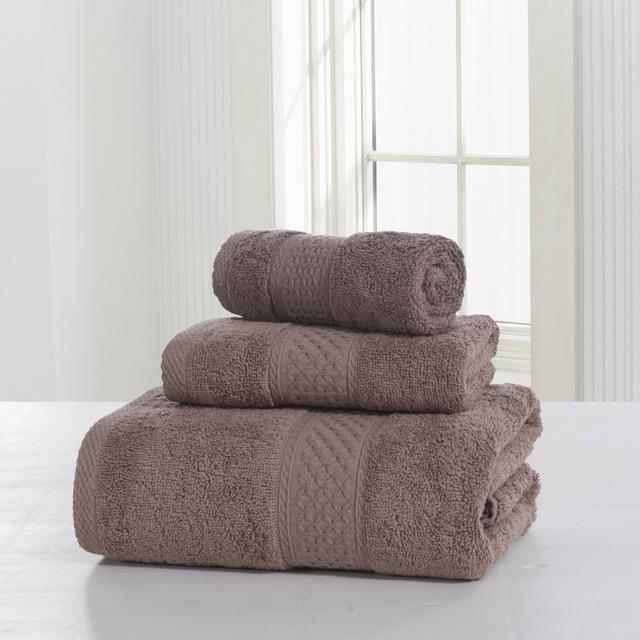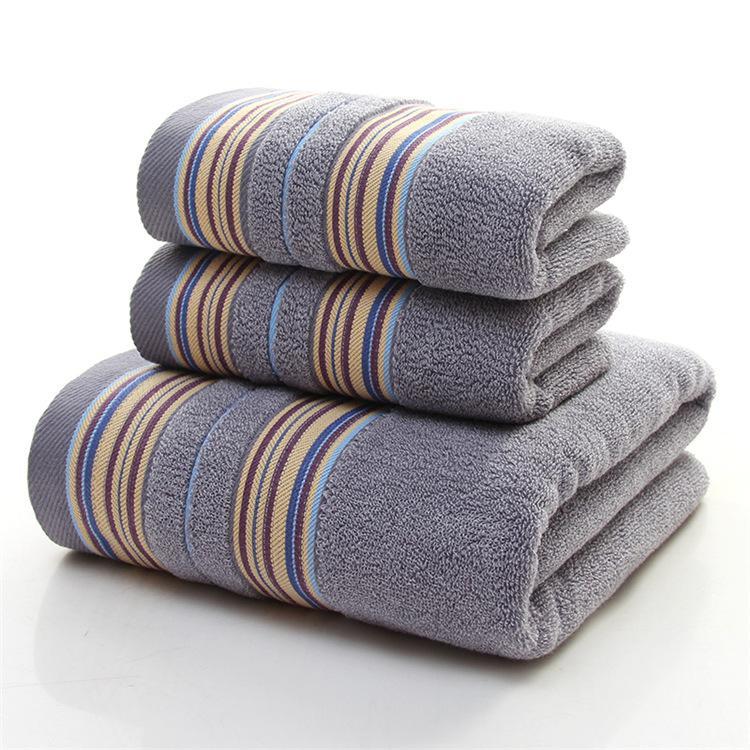The first image is the image on the left, the second image is the image on the right. Evaluate the accuracy of this statement regarding the images: "The stack of towels in one of the pictures is made up of only identical sized towels.". Is it true? Answer yes or no. No. The first image is the image on the left, the second image is the image on the right. For the images displayed, is the sentence "There is a stack of all pink towels in one image." factually correct? Answer yes or no. No. 